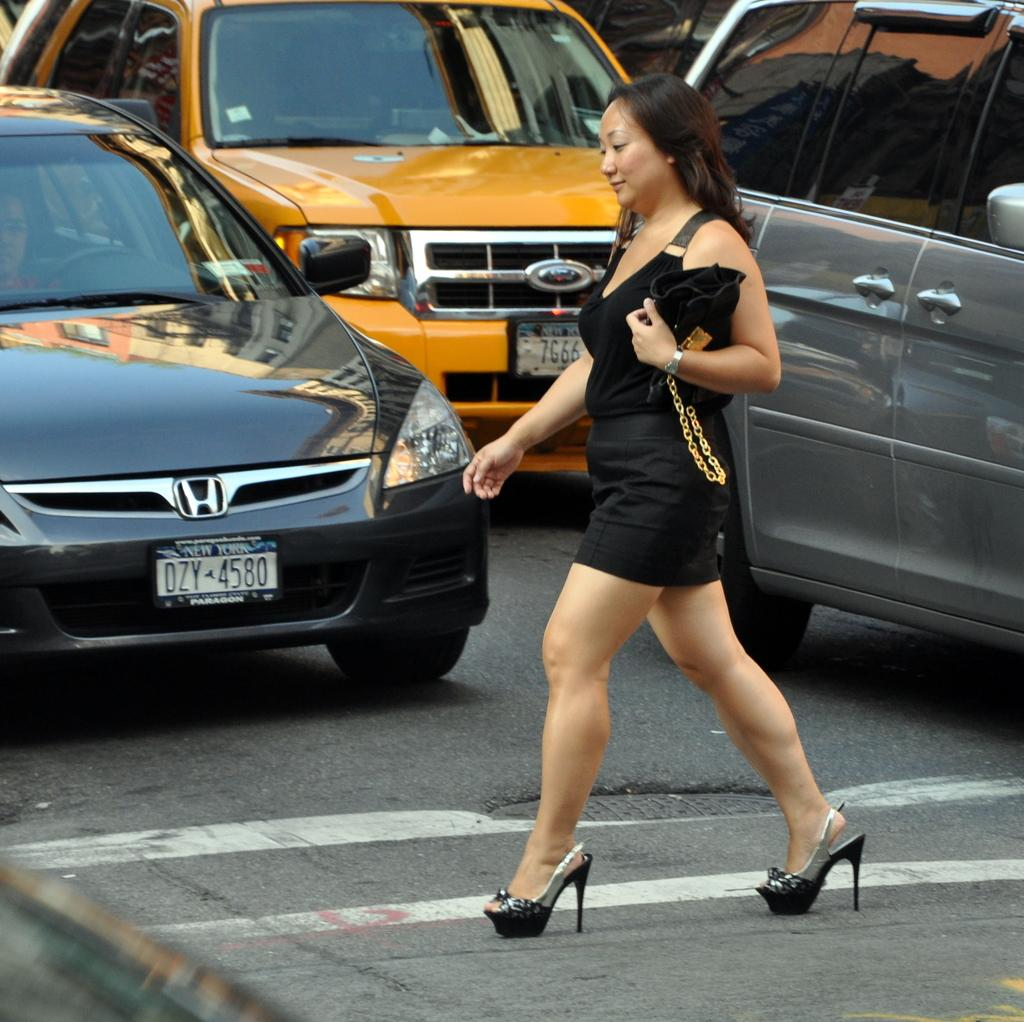<image>
Relay a brief, clear account of the picture shown. A woman crossing the street in front of a car with the license plate DZY 4580. 